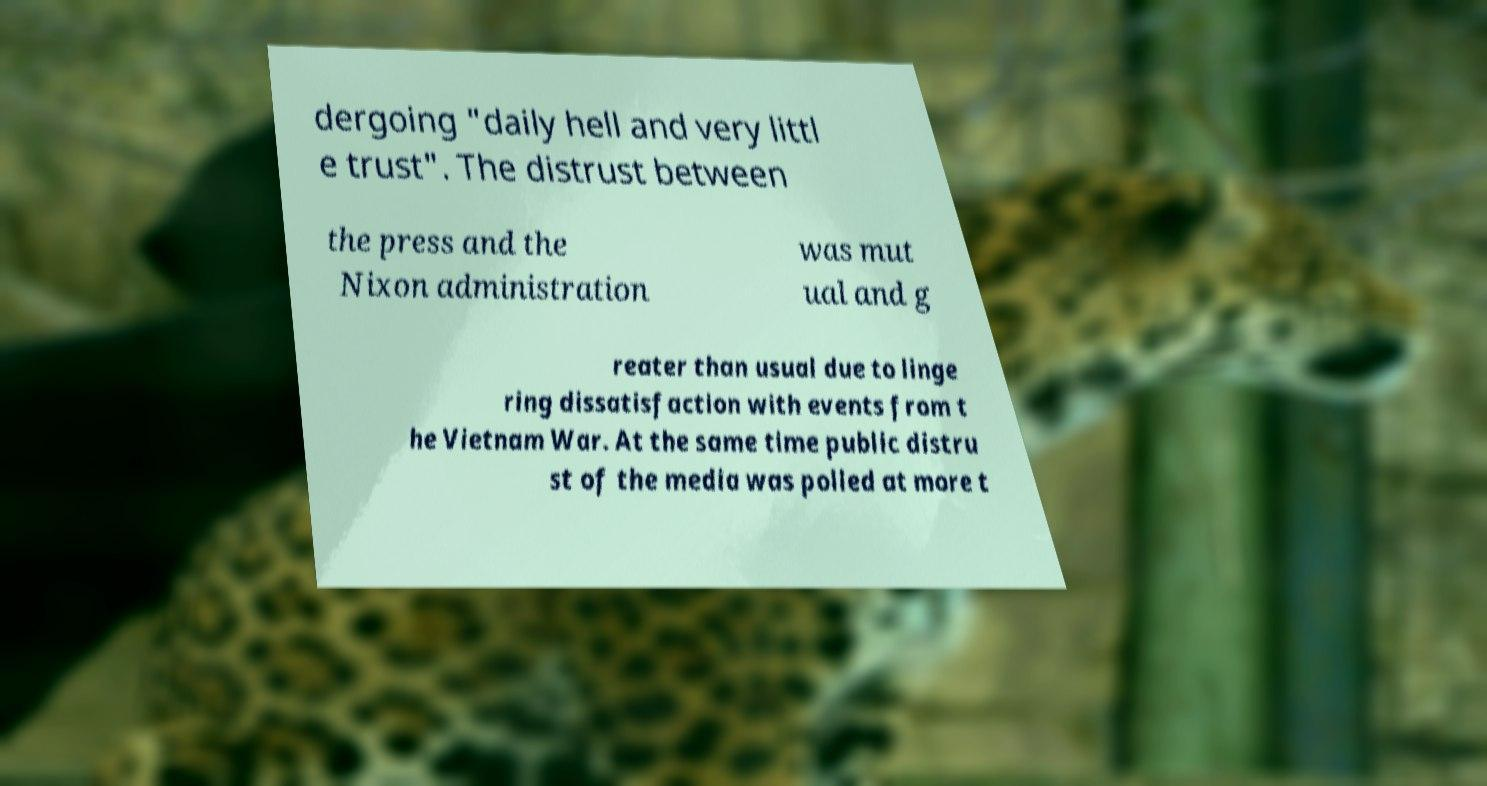Can you read and provide the text displayed in the image?This photo seems to have some interesting text. Can you extract and type it out for me? dergoing "daily hell and very littl e trust". The distrust between the press and the Nixon administration was mut ual and g reater than usual due to linge ring dissatisfaction with events from t he Vietnam War. At the same time public distru st of the media was polled at more t 